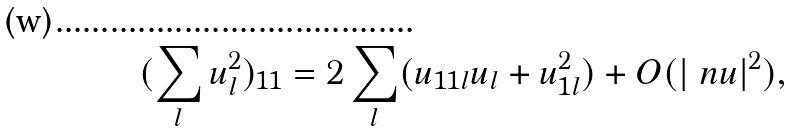<formula> <loc_0><loc_0><loc_500><loc_500>( \sum _ { l } u _ { l } ^ { 2 } ) _ { 1 1 } = 2 \sum _ { l } ( u _ { 1 1 l } u _ { l } + u _ { 1 l } ^ { 2 } ) + O ( | \ n u | ^ { 2 } ) ,</formula> 